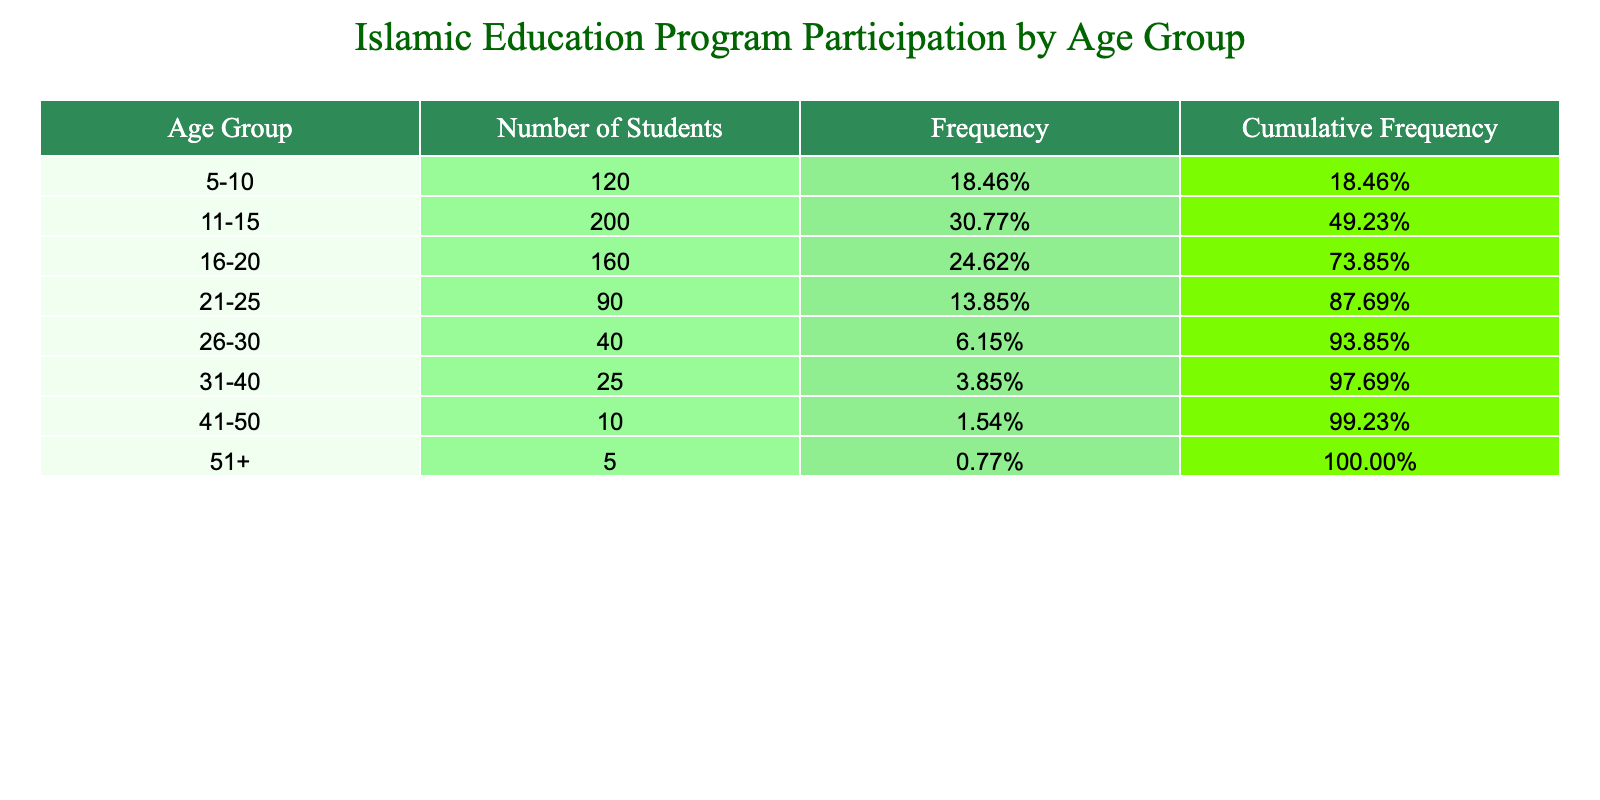What is the total number of students participating in Islamic education programs? To find the total number of students, we add up the values in the "Number of Students" column: 120 + 200 + 160 + 90 + 40 + 25 + 10 + 5 = 650
Answer: 650 Which age group has the highest number of students? By comparing the "Number of Students" across all age groups, we see that the age group 11-15 has the highest number, with 200 students.
Answer: 11-15 What is the frequency of students in the age group 21-25? The frequency for the age group 21-25 is calculated by dividing the number of students in this group by the total number of students. So, Frequency = 90 / 650 ≈ 0.138 or 13.85%.
Answer: 13.85% Is there any age group with more than 100 students? By examining the "Number of Students," we see the age groups 5-10 (120), 11-15 (200), and 16-20 (160) all have more than 100 students.
Answer: Yes What is the cumulative frequency for the age group 16-20? To find the cumulative frequency for the age group 16-20, we add the frequency of this group to the frequencies of all preceding groups. The frequencies are: 5-10 (120/650), 11-15 (200/650), and 16-20 (160/650). So, cumulative frequency = (120 + 200 + 160) / 650 = 480 / 650 ≈ 0.738 or 73.85%.
Answer: 73.85% Which age group has the lowest number of students, and how many are there? From the "Number of Students," we see the age group 51+ has the lowest number, with only 5 students.
Answer: 51+, 5 How many students are there in age groups 26-30 and older (31+)? We calculate the sum of the number of students in the 26-30 age group (40) and those in age groups 31-40 (25), 41-50 (10), and 51+ (5). So, Total = 40 + 25 + 10 + 5 = 80.
Answer: 80 What percentage of students are aged 30 and older? To find this percentage, first add the number of students in the age groups 31-40 (25), 41-50 (10), and 51+ (5). This equals 25 + 10 + 5 = 40. The percentage is then calculated as (40 / 650) * 100 ≈ 6.15%.
Answer: 6.15% 